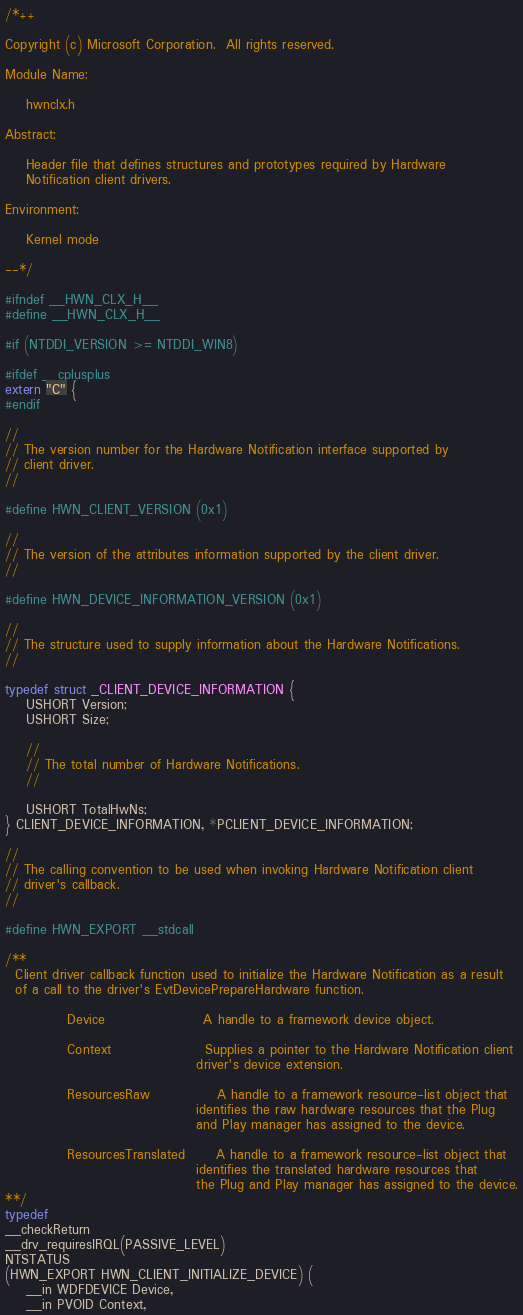<code> <loc_0><loc_0><loc_500><loc_500><_C_>/*++

Copyright (c) Microsoft Corporation.  All rights reserved.

Module Name:

    hwnclx.h

Abstract:

    Header file that defines structures and prototypes required by Hardware
    Notification client drivers.

Environment:

    Kernel mode

--*/

#ifndef __HWN_CLX_H__
#define __HWN_CLX_H__

#if (NTDDI_VERSION >= NTDDI_WIN8)

#ifdef __cplusplus
extern "C" {
#endif

//
// The version number for the Hardware Notification interface supported by
// client driver.
//

#define HWN_CLIENT_VERSION (0x1)

//
// The version of the attributes information supported by the client driver.
//

#define HWN_DEVICE_INFORMATION_VERSION (0x1)

//
// The structure used to supply information about the Hardware Notifications.
//

typedef struct _CLIENT_DEVICE_INFORMATION {
    USHORT Version;
    USHORT Size;

    //
    // The total number of Hardware Notifications.
    //

    USHORT TotalHwNs;
} CLIENT_DEVICE_INFORMATION, *PCLIENT_DEVICE_INFORMATION;

//
// The calling convention to be used when invoking Hardware Notification client
// driver's callback.
//

#define HWN_EXPORT __stdcall

/**
  Client driver callback function used to initialize the Hardware Notification as a result
  of a call to the driver's EvtDevicePrepareHardware function.

            Device                   A handle to a framework device object.

            Context                  Supplies a pointer to the Hardware Notification client
                                     driver's device extension.

            ResourcesRaw             A handle to a framework resource-list object that
                                     identifies the raw hardware resources that the Plug
                                     and Play manager has assigned to the device.

            ResourcesTranslated      A handle to a framework resource-list object that
                                     identifies the translated hardware resources that
                                     the Plug and Play manager has assigned to the device.
**/
typedef
__checkReturn
__drv_requiresIRQL(PASSIVE_LEVEL)
NTSTATUS
(HWN_EXPORT HWN_CLIENT_INITIALIZE_DEVICE) (
    __in WDFDEVICE Device,
    __in PVOID Context,</code> 